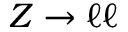Convert formula to latex. <formula><loc_0><loc_0><loc_500><loc_500>Z \to \ell \ell</formula> 